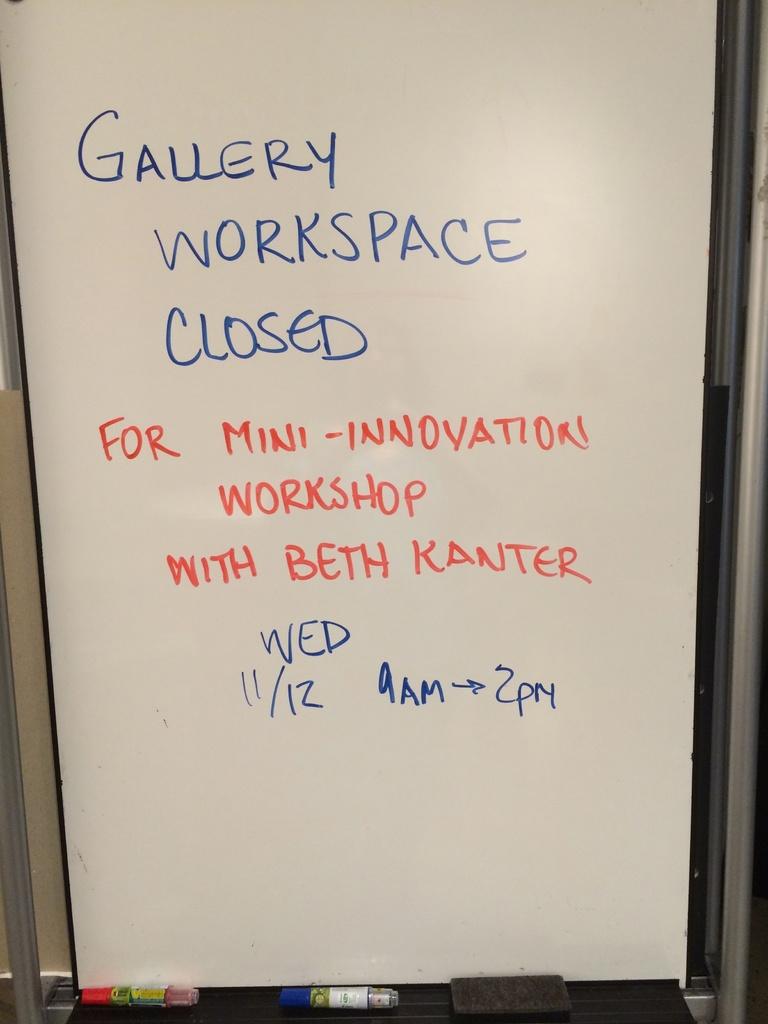What place is closed?
Make the answer very short. Gallery workspace. Who is leading the mini-innovation workshop?
Offer a very short reply. Beth kanter. 